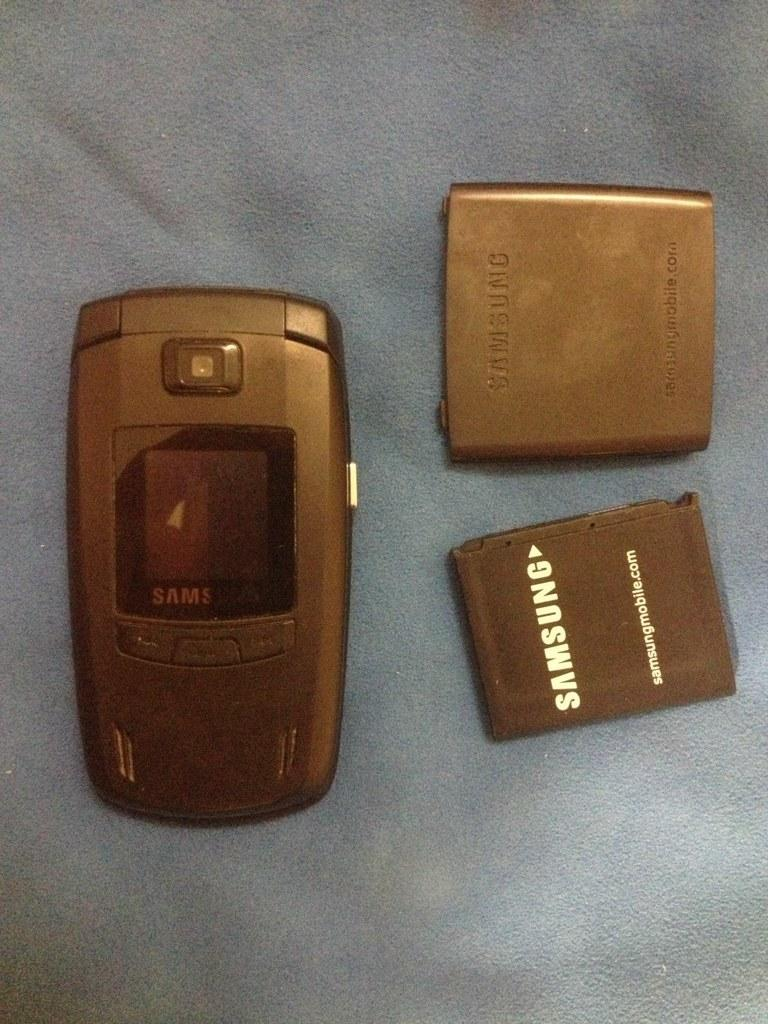<image>
Provide a brief description of the given image. Gold Samsung cellphone next to the Samsung battery. 